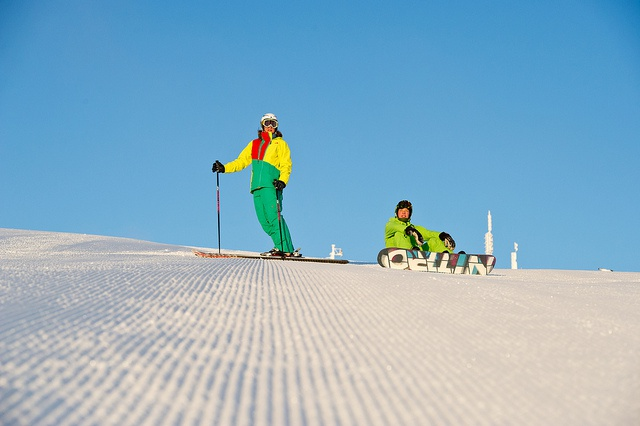Describe the objects in this image and their specific colors. I can see people in teal, green, gold, black, and red tones, snowboard in teal, beige, gray, and tan tones, people in teal, khaki, black, olive, and darkgreen tones, and skis in teal, black, darkgray, lightgray, and tan tones in this image. 